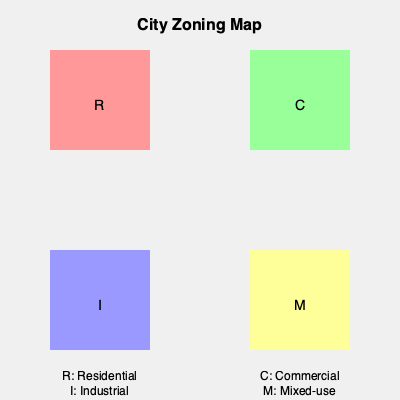Based on the color-coded zoning map of a U.S. city, which zone (represented by the yellow square) allows for a combination of residential, commercial, and potentially light industrial uses within the same area? To answer this question, let's break down the information provided in the zoning map:

1. The map shows four different colored squares, each representing a different zoning type.
2. Each square is labeled with a letter that corresponds to a specific zoning category:
   - R (Red): Residential
   - C (Green): Commercial
   - I (Blue): Industrial
   - M (Yellow): Mixed-use

3. The question asks about the zone that allows a combination of residential, commercial, and potentially light industrial uses.
4. In U.S. urban planning, "mixed-use" zoning is specifically designed to allow a blend of residential, commercial, and sometimes light industrial uses within the same area.
5. Looking at the map legend, we can see that the yellow square labeled "M" represents Mixed-use zoning.

Therefore, the yellow square (M) on the map represents the zone that allows for a combination of different uses, including residential, commercial, and potentially light industrial.
Answer: Mixed-use (M) 